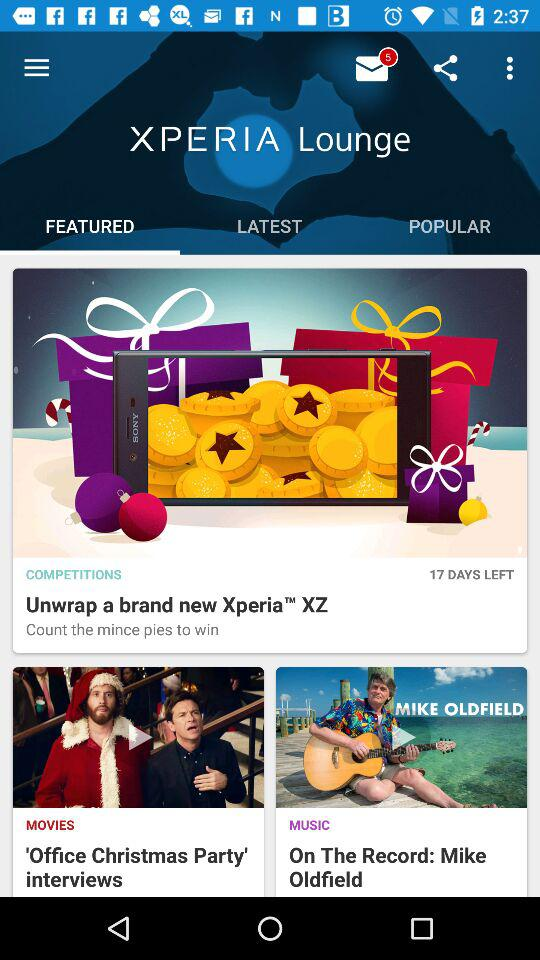Which tab is selected? The selected tab is "FEATURED". 